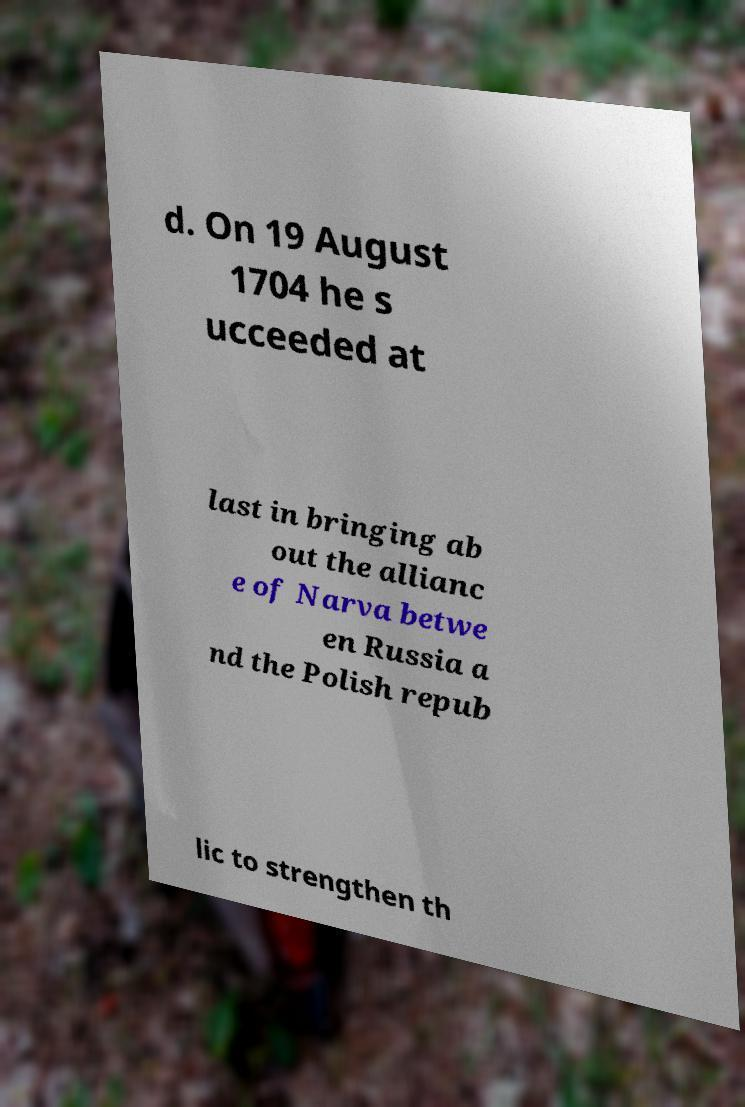Please read and relay the text visible in this image. What does it say? d. On 19 August 1704 he s ucceeded at last in bringing ab out the allianc e of Narva betwe en Russia a nd the Polish repub lic to strengthen th 